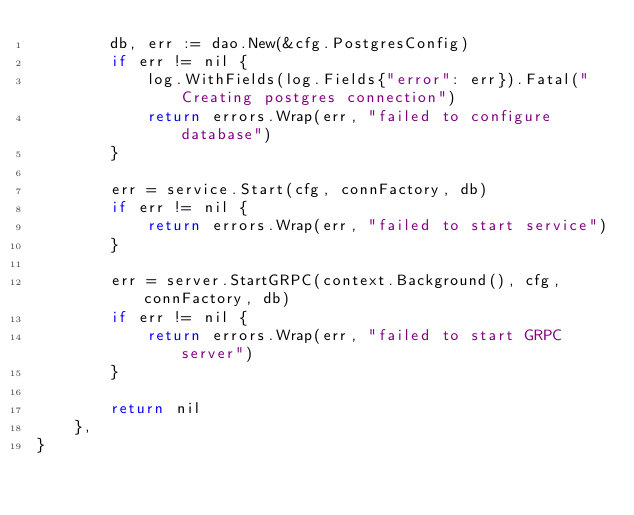Convert code to text. <code><loc_0><loc_0><loc_500><loc_500><_Go_>		db, err := dao.New(&cfg.PostgresConfig)
		if err != nil {
			log.WithFields(log.Fields{"error": err}).Fatal("Creating postgres connection")
			return errors.Wrap(err, "failed to configure database")
		}

		err = service.Start(cfg, connFactory, db)
		if err != nil {
			return errors.Wrap(err, "failed to start service")
		}

		err = server.StartGRPC(context.Background(), cfg, connFactory, db)
		if err != nil {
			return errors.Wrap(err, "failed to start GRPC server")
		}

		return nil
	},
}
</code> 